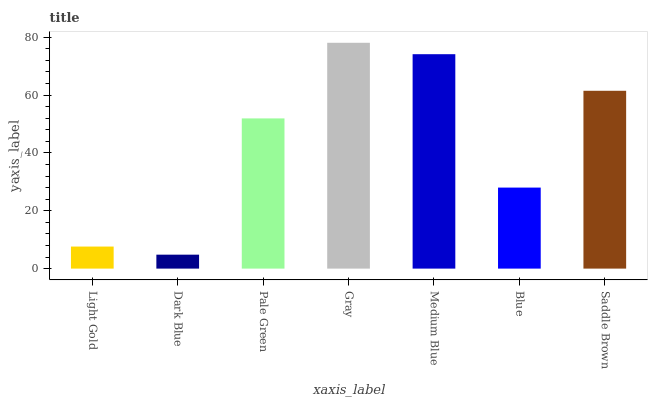Is Dark Blue the minimum?
Answer yes or no. Yes. Is Gray the maximum?
Answer yes or no. Yes. Is Pale Green the minimum?
Answer yes or no. No. Is Pale Green the maximum?
Answer yes or no. No. Is Pale Green greater than Dark Blue?
Answer yes or no. Yes. Is Dark Blue less than Pale Green?
Answer yes or no. Yes. Is Dark Blue greater than Pale Green?
Answer yes or no. No. Is Pale Green less than Dark Blue?
Answer yes or no. No. Is Pale Green the high median?
Answer yes or no. Yes. Is Pale Green the low median?
Answer yes or no. Yes. Is Saddle Brown the high median?
Answer yes or no. No. Is Saddle Brown the low median?
Answer yes or no. No. 